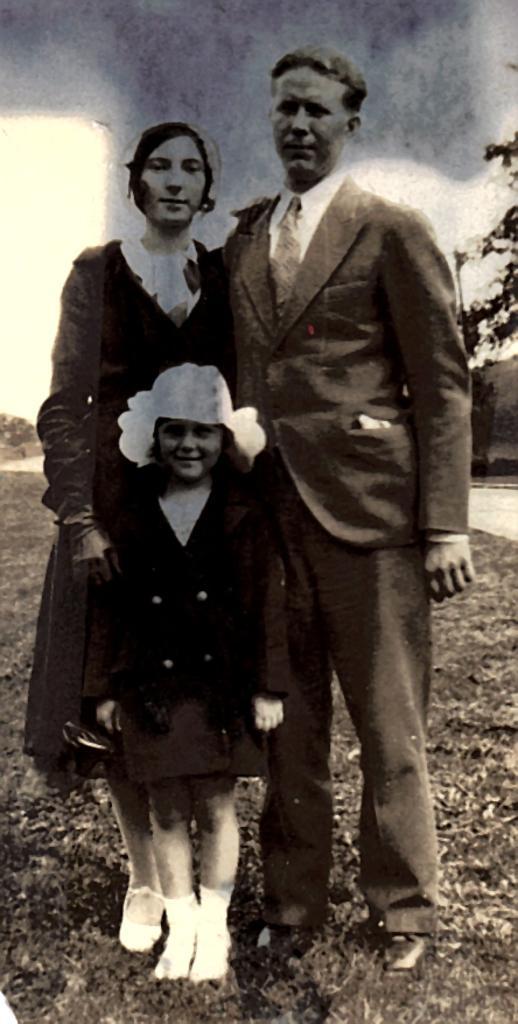How would you summarize this image in a sentence or two? In the middle of the image few people are standing and smiling. Behind them there is grass and trees. 